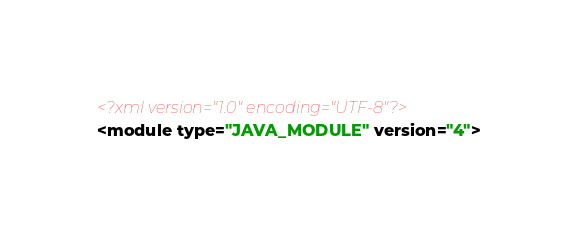Convert code to text. <code><loc_0><loc_0><loc_500><loc_500><_XML_><?xml version="1.0" encoding="UTF-8"?>
<module type="JAVA_MODULE" version="4"></code> 